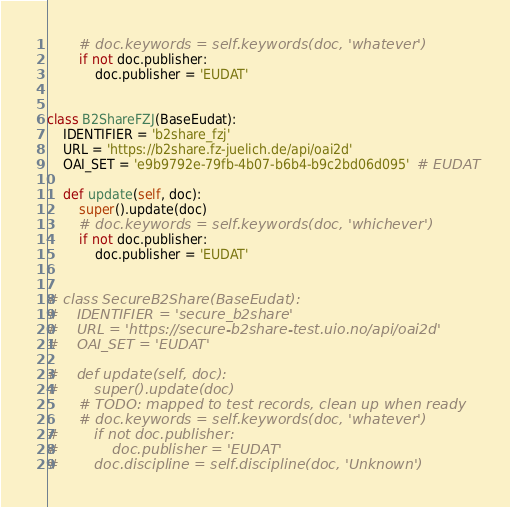<code> <loc_0><loc_0><loc_500><loc_500><_Python_>        # doc.keywords = self.keywords(doc, 'whatever')
        if not doc.publisher:
            doc.publisher = 'EUDAT'


class B2ShareFZJ(BaseEudat):
    IDENTIFIER = 'b2share_fzj'
    URL = 'https://b2share.fz-juelich.de/api/oai2d'
    OAI_SET = 'e9b9792e-79fb-4b07-b6b4-b9c2bd06d095'  # EUDAT

    def update(self, doc):
        super().update(doc)
        # doc.keywords = self.keywords(doc, 'whichever')
        if not doc.publisher:
            doc.publisher = 'EUDAT'


# class SecureB2Share(BaseEudat):
#    IDENTIFIER = 'secure_b2share'
#    URL = 'https://secure-b2share-test.uio.no/api/oai2d'
#    OAI_SET = 'EUDAT'

#    def update(self, doc):
#        super().update(doc)
        # TODO: mapped to test records, clean up when ready
        # doc.keywords = self.keywords(doc, 'whatever')
#        if not doc.publisher:
#            doc.publisher = 'EUDAT'
#        doc.discipline = self.discipline(doc, 'Unknown')
</code> 